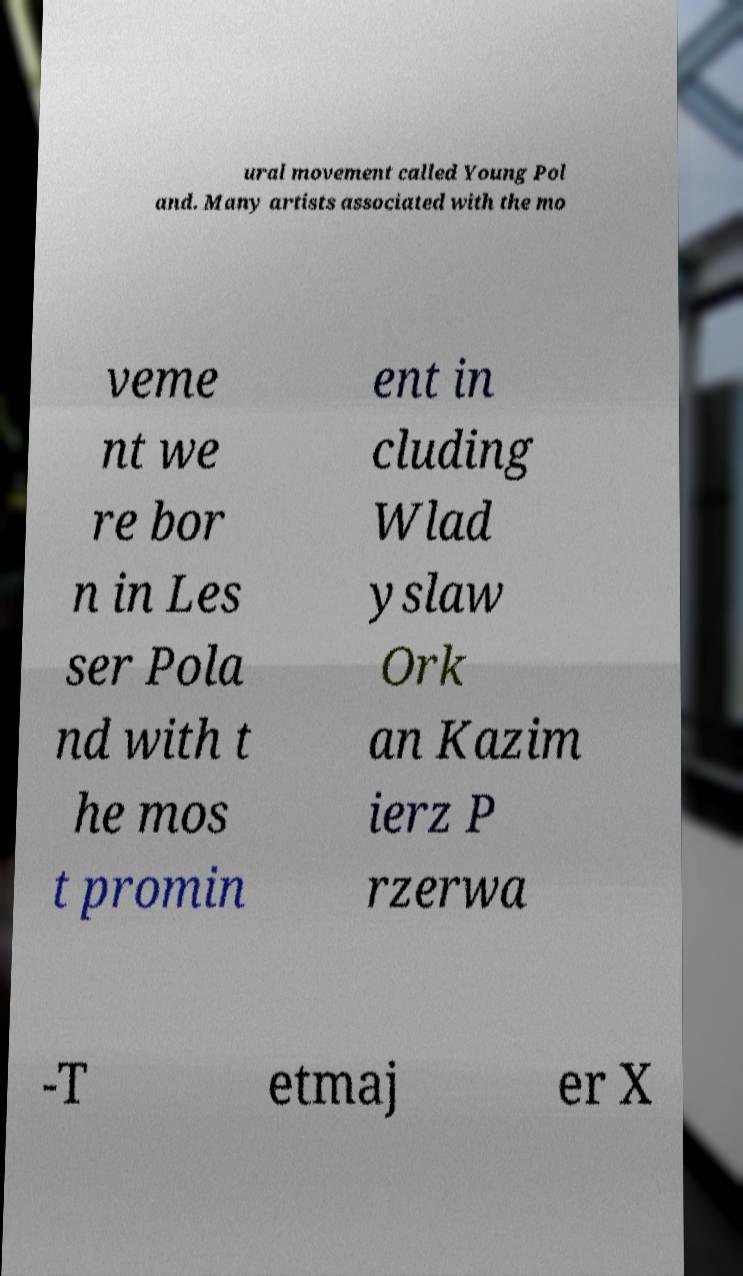Can you read and provide the text displayed in the image?This photo seems to have some interesting text. Can you extract and type it out for me? ural movement called Young Pol and. Many artists associated with the mo veme nt we re bor n in Les ser Pola nd with t he mos t promin ent in cluding Wlad yslaw Ork an Kazim ierz P rzerwa -T etmaj er X 